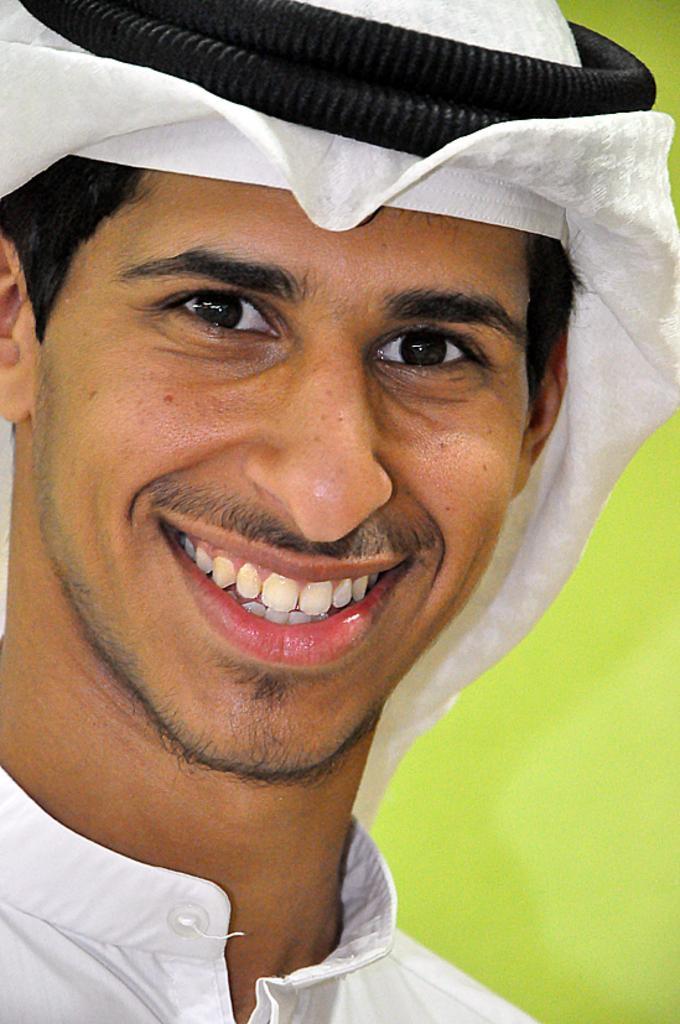Please provide a concise description of this image. In front of the image there is a person having a smile on his face. Behind him there is a wall. 